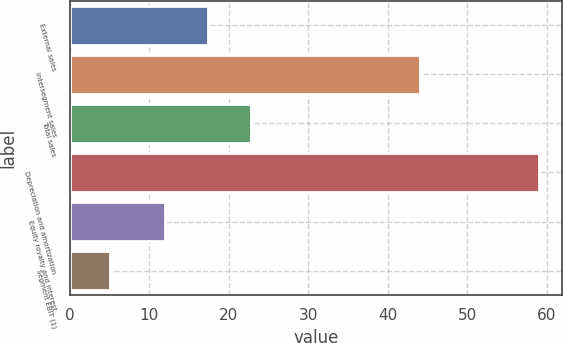<chart> <loc_0><loc_0><loc_500><loc_500><bar_chart><fcel>External sales<fcel>Intersegment sales<fcel>Total sales<fcel>Depreciation and amortization<fcel>Equity royalty and interest<fcel>Segment EBIT (1)<nl><fcel>17.4<fcel>44<fcel>22.8<fcel>59<fcel>12<fcel>5<nl></chart> 